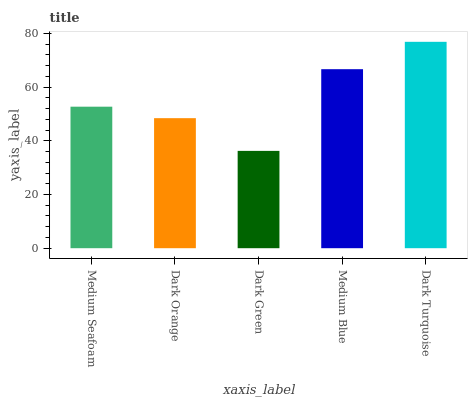Is Dark Green the minimum?
Answer yes or no. Yes. Is Dark Turquoise the maximum?
Answer yes or no. Yes. Is Dark Orange the minimum?
Answer yes or no. No. Is Dark Orange the maximum?
Answer yes or no. No. Is Medium Seafoam greater than Dark Orange?
Answer yes or no. Yes. Is Dark Orange less than Medium Seafoam?
Answer yes or no. Yes. Is Dark Orange greater than Medium Seafoam?
Answer yes or no. No. Is Medium Seafoam less than Dark Orange?
Answer yes or no. No. Is Medium Seafoam the high median?
Answer yes or no. Yes. Is Medium Seafoam the low median?
Answer yes or no. Yes. Is Dark Turquoise the high median?
Answer yes or no. No. Is Dark Orange the low median?
Answer yes or no. No. 